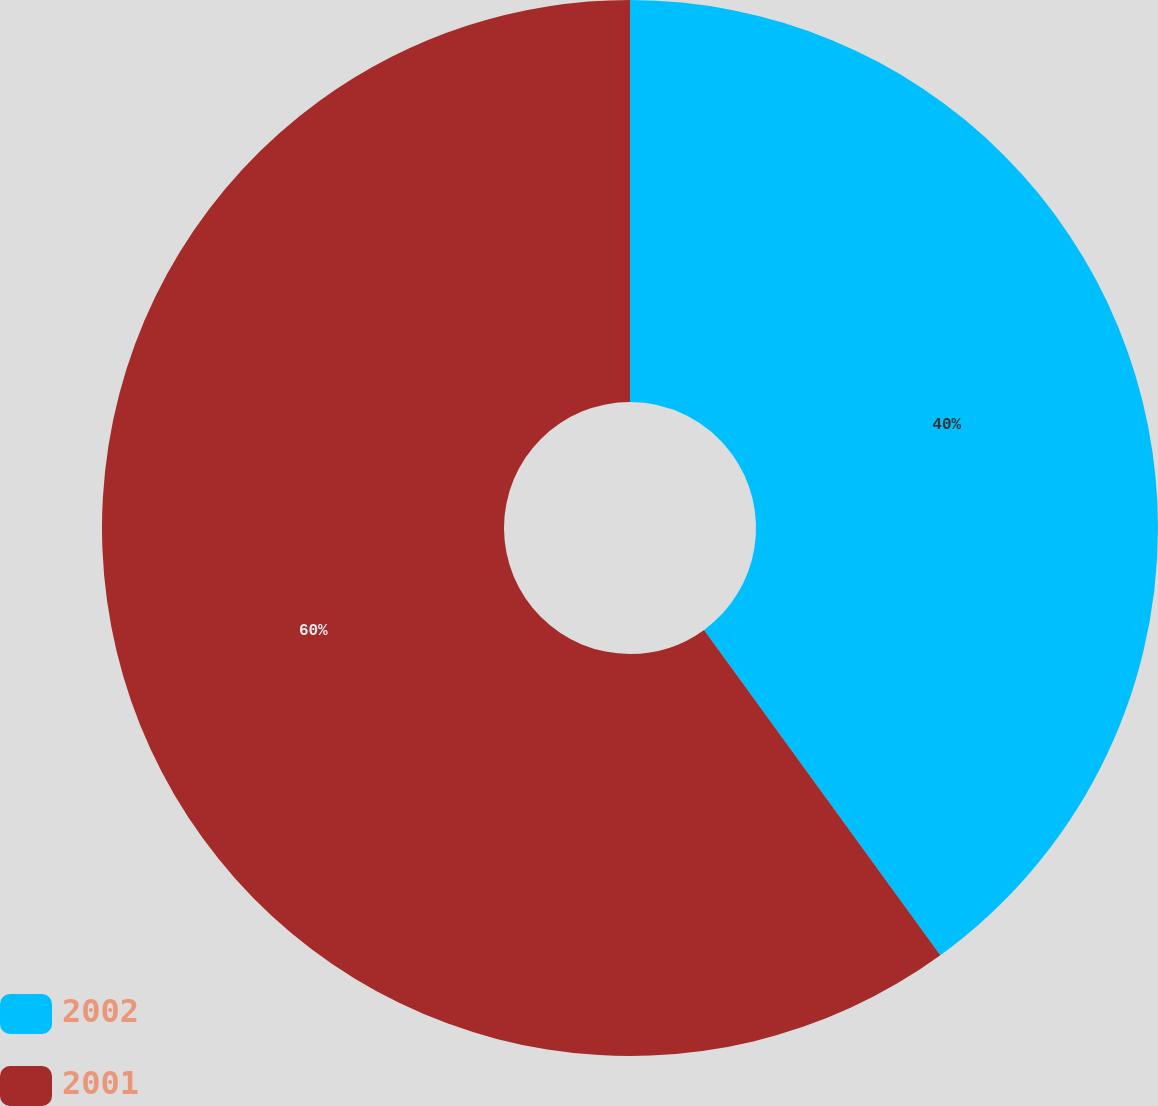<chart> <loc_0><loc_0><loc_500><loc_500><pie_chart><fcel>2002<fcel>2001<nl><fcel>40.0%<fcel>60.0%<nl></chart> 